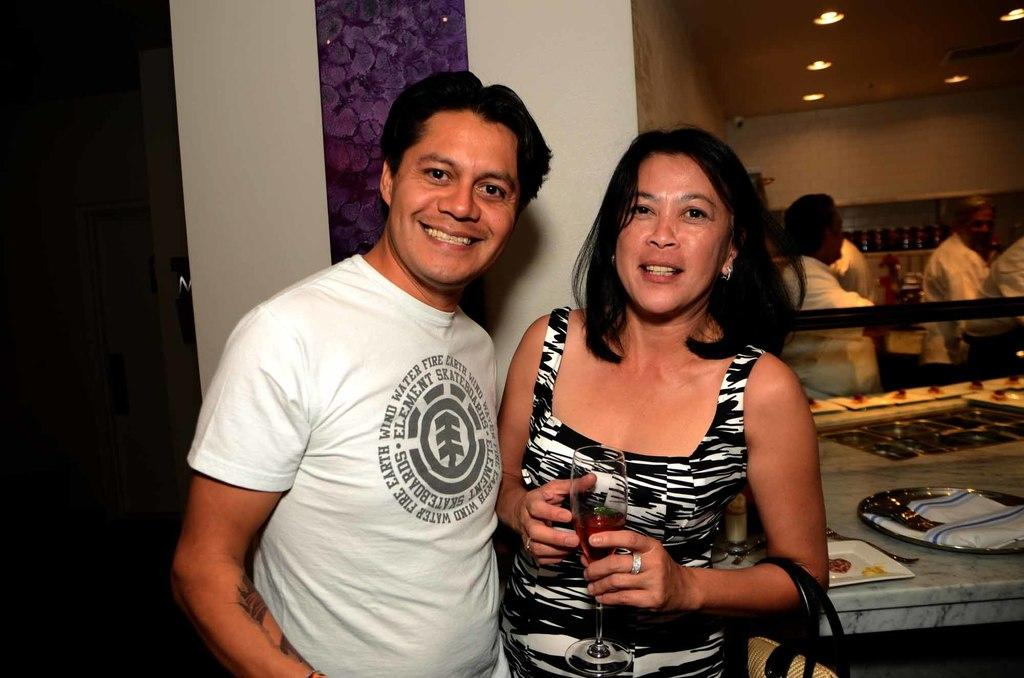How many people are present in the image? There are two people, a woman and a man, present in the image. What can be seen in the background of the image? There is a wall and other persons standing in the background of the image. Can you describe the lighting in the image? Yes, there is a light visible in the image. What type of books are the mom reading in the image? There is no mom present in the image, and no books are visible. 